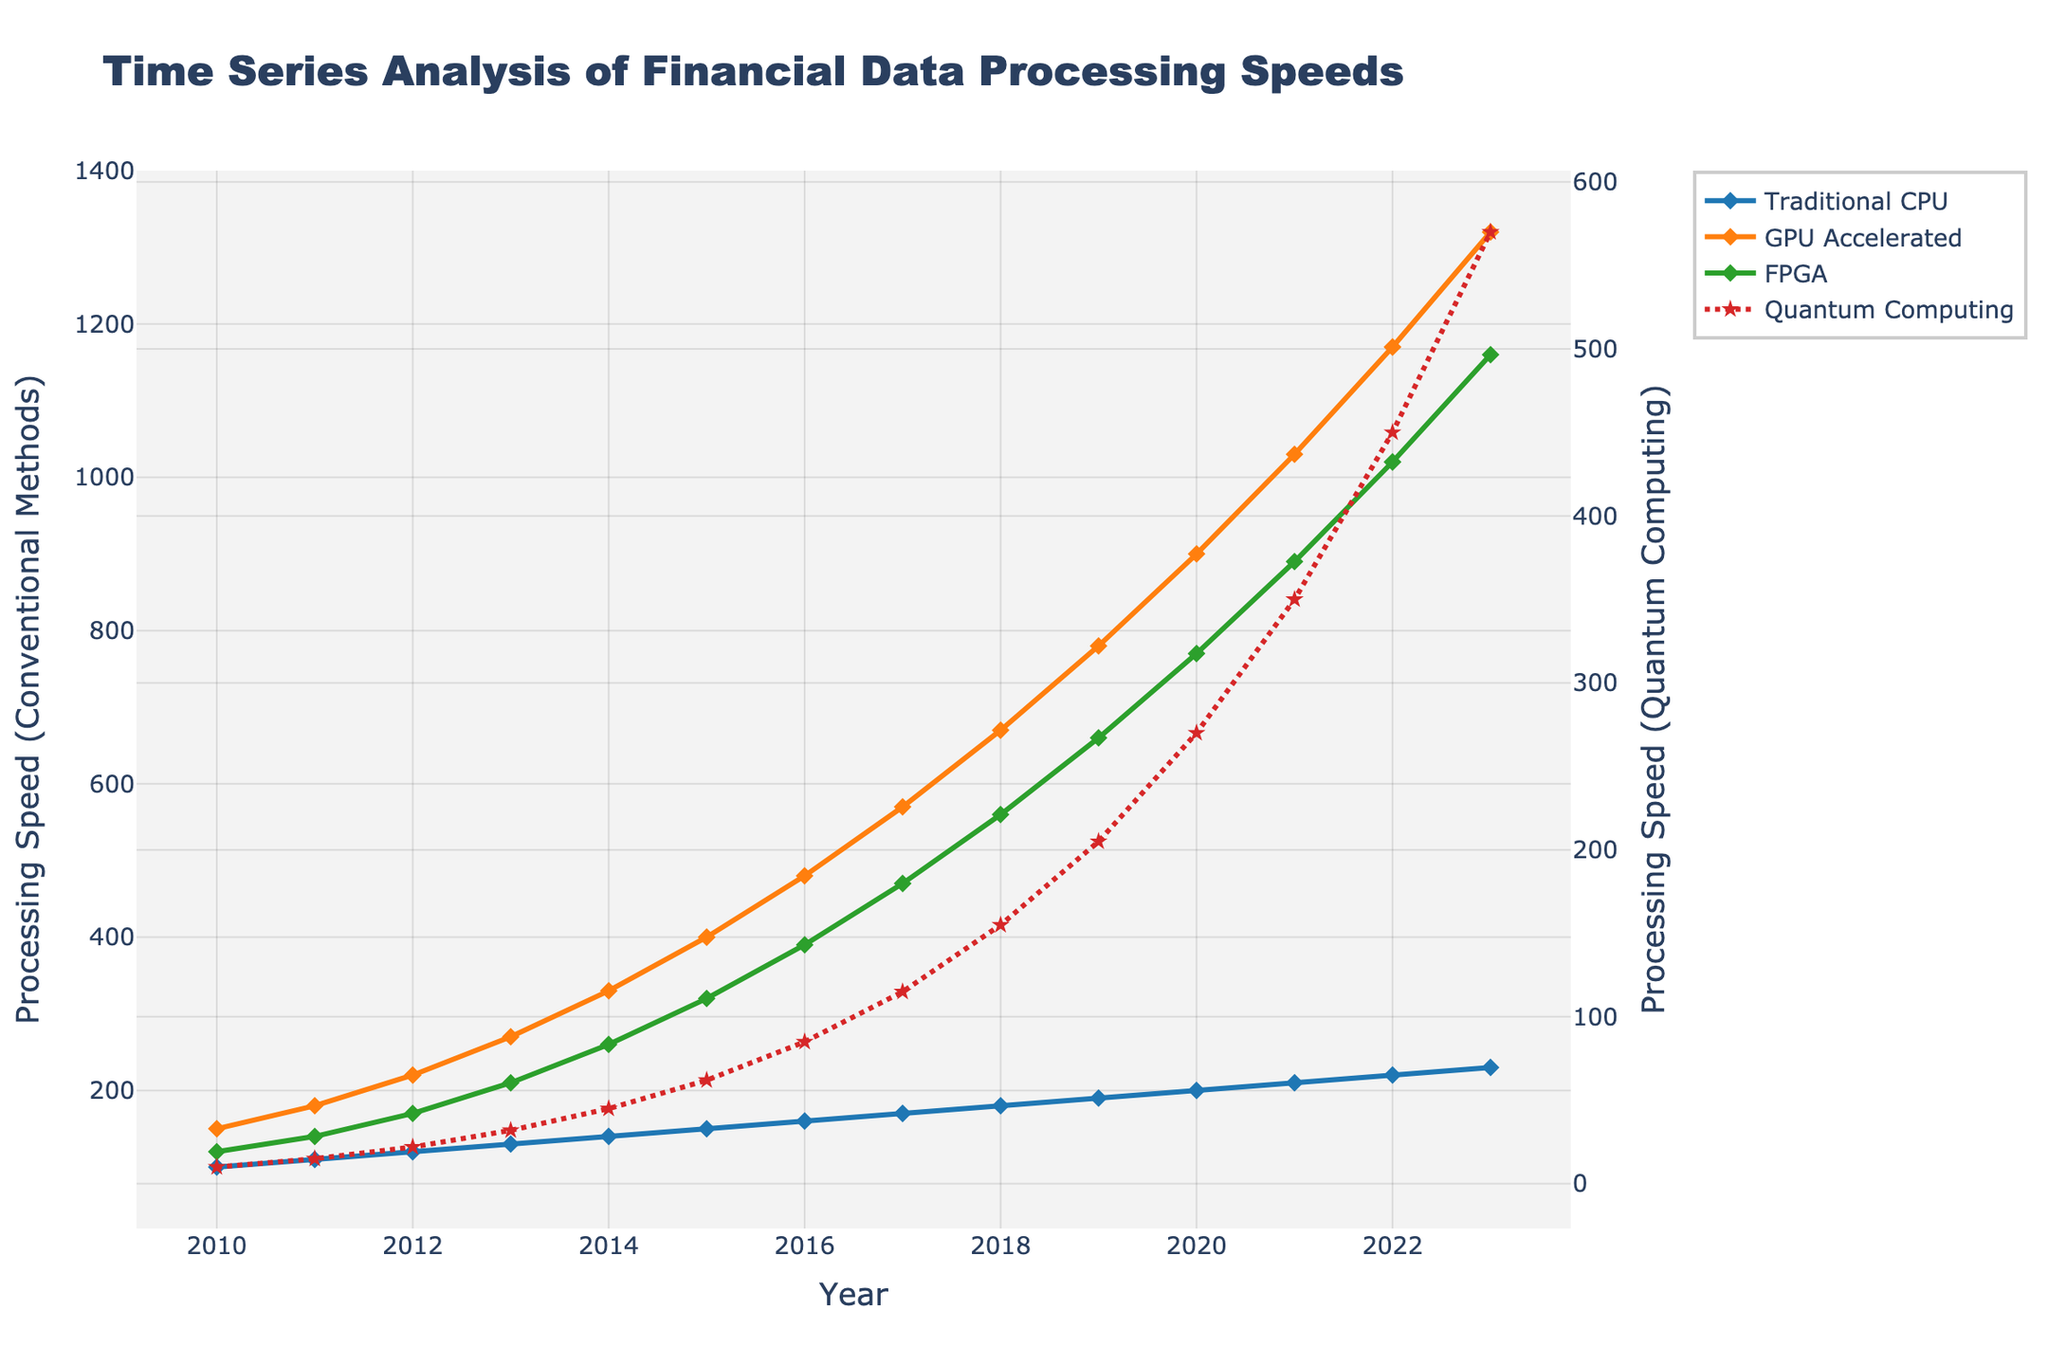Which computational method has the highest processing speed by 2023? By 2023, you need to compare the end values of all the methods. Quantum Computing shows the highest processing speed at 570.
Answer: Quantum Computing How did the processing speed change for traditional CPUs from 2010 to 2015? For the years 2010 to 2015, traditional CPUs had speeds of 100, 110, 120, 130, 140, and 150 respectively. So, the increase from 100 to 150 is 150 - 100 = 50.
Answer: Increased by 50 What is the difference in processing speed between GPU Accelerated and FPGA in 2020? In 2020, GPU Accelerated is at 900 and FPGA is at 770. The difference is 900 - 770 = 130.
Answer: 130 Which method experienced the steepest growth rate visually between 2015 and 2020? From the visual perspective, GPU Accelerated shows the steepest upward trend between 2015 (400) and 2020 (900).
Answer: GPU Accelerated What is the average processing speed for FPGA over the entire period? The average processing speed is found by summing all FPGA speeds and dividing by the number of years. Sum is 120 + 140 + 170 + 210 + 260 + 320 + 390 + 470 + 560 + 660 + 770 + 890 + 1020 + 1160 = 8140. Average is 8140/14 = 581.43.
Answer: 581.43 How much did quantum computing processing speed increase from 2013 to 2023? Quantum computing increased from 32 in 2013 to 570 in 2023. The difference is 570 - 32 = 538.
Answer: 538 Between which consecutive years did GPU Accelerated show the largest increase? Looking at GPU Accelerated, between 2021 and 2022, it increased from 1030 to 1170 (140 units), which is the largest yearly increase.
Answer: Between 2021 and 2022 Which method consistently shows a linear growth pattern? Traditional CPU consistently increases by 10 units each year, indicating a linear growth pattern.
Answer: Traditional CPU How does the processing speed of FPGA in 2018 compare with Quantum Computing? In 2018, FPGA is at 560 while Quantum Computing is at 155. Comparing these, FPGA has a higher processing speed.
Answer: FPGA is higher What is the cumulative processing speed for GPU Accelerated from 2010 to 2023? Adding all processing speeds: 150 + 180 + 220 + 270 + 330 + 400 + 480 + 570 + 670 + 780 + 900 + 1030 + 1170 + 1320 = 8470.
Answer: 8470 